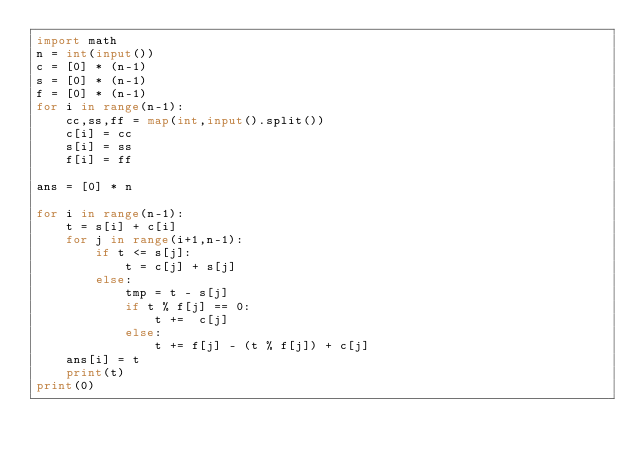Convert code to text. <code><loc_0><loc_0><loc_500><loc_500><_Python_>import math
n = int(input())
c = [0] * (n-1)
s = [0] * (n-1)
f = [0] * (n-1)
for i in range(n-1):
    cc,ss,ff = map(int,input().split())
    c[i] = cc
    s[i] = ss
    f[i] = ff

ans = [0] * n

for i in range(n-1):
    t = s[i] + c[i]
    for j in range(i+1,n-1):
        if t <= s[j]:
            t = c[j] + s[j]
        else:
            tmp = t - s[j]
            if t % f[j] == 0:
                t +=  c[j]
            else:
                t += f[j] - (t % f[j]) + c[j]
    ans[i] = t
    print(t)
print(0)
</code> 